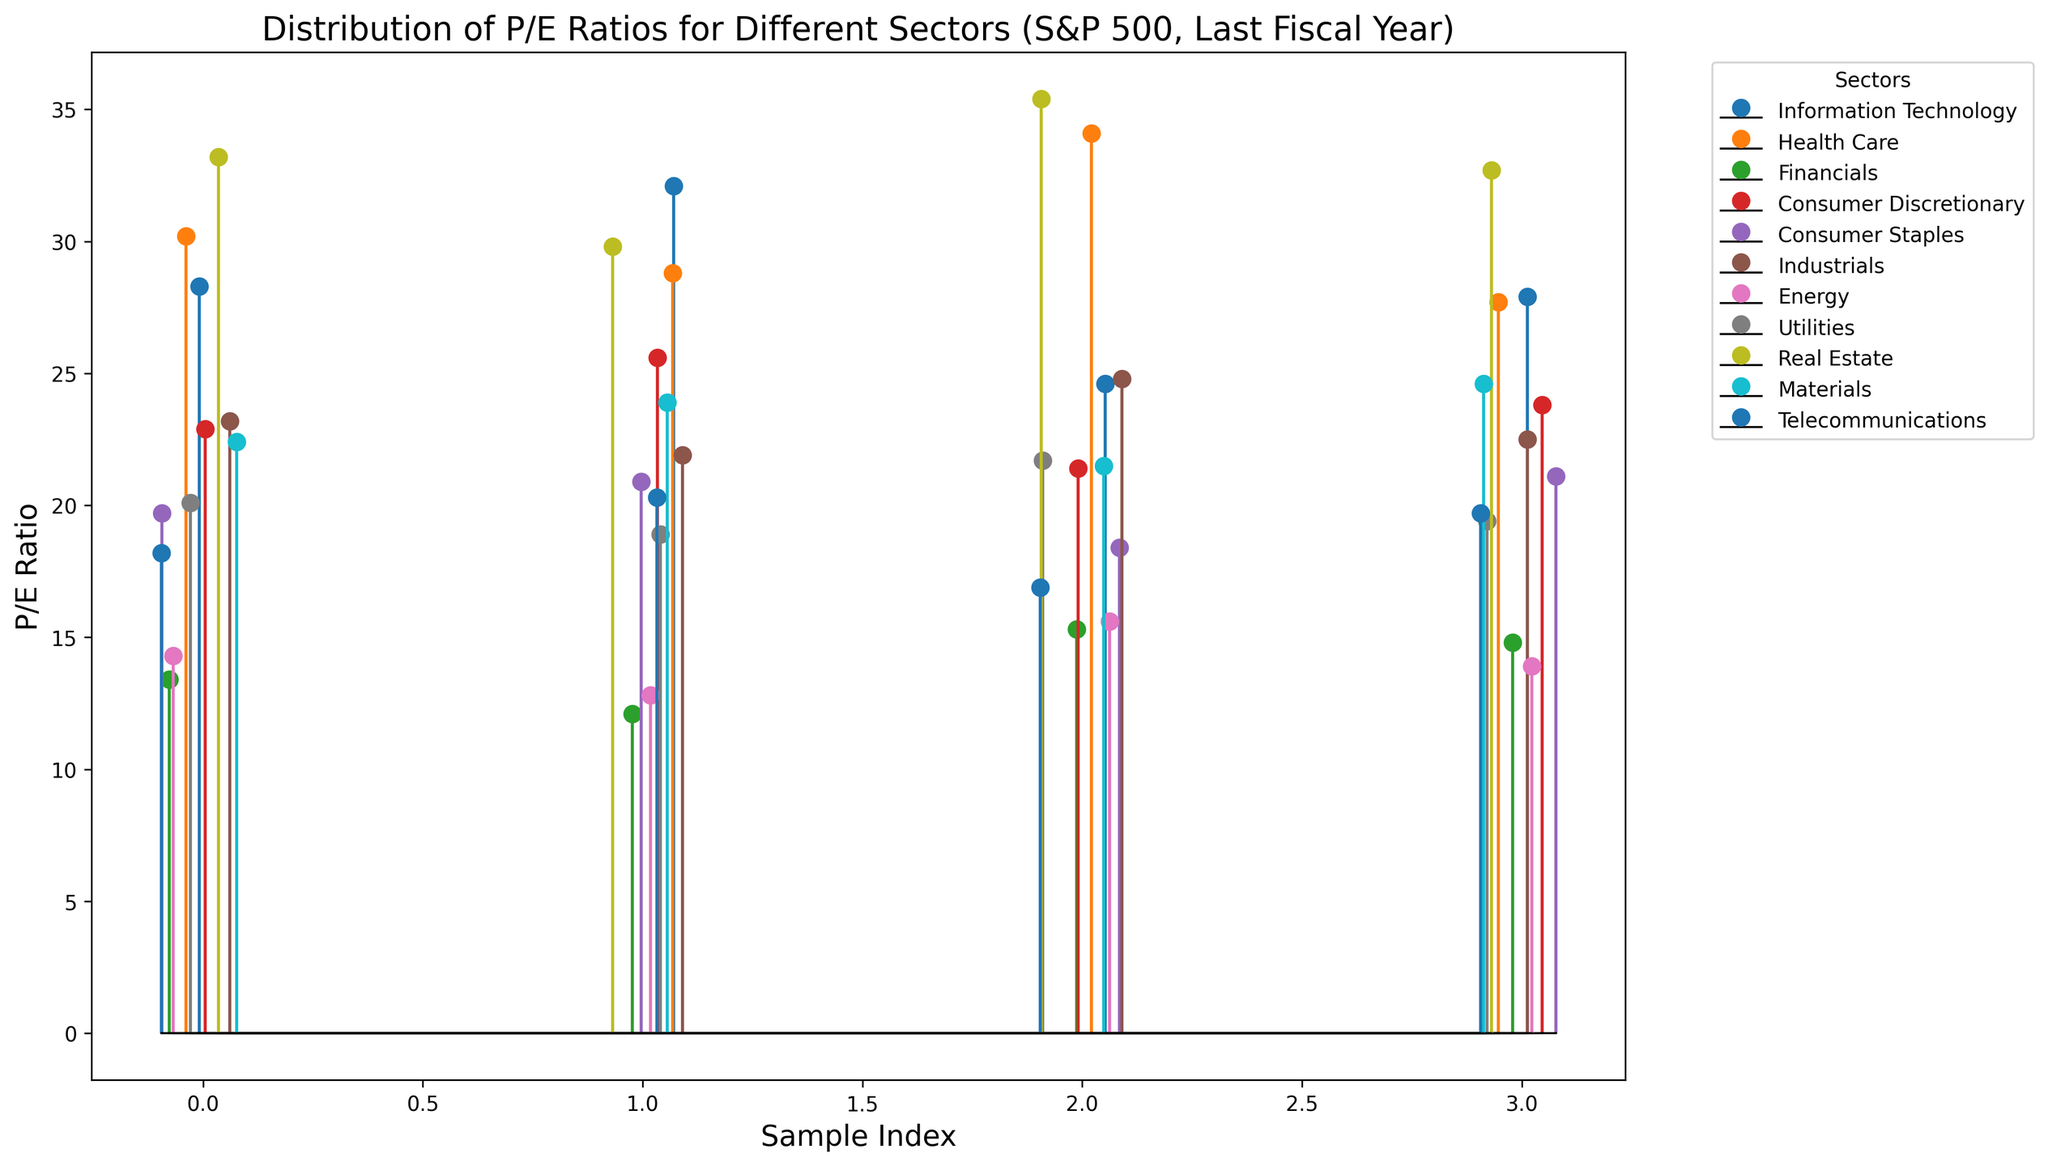What's the sector with the highest average P/E ratio? To find the sector with the highest average P/E ratio, first, calculate the average P/E for each sector by summing the P/E ratios of each sector and dividing by the number of data points. Information Technology (28.3+32.1+24.6+27.9)/4 = 28.225, Health Care (30.2+28.8+34.1+27.7)/4 = 30.2, Financials (13.4+12.1+15.3+14.8)/4 = 13.9, Consumer Discretionary (22.9+25.6+21.4+23.8)/4 = 23.425, Consumer Staples (19.7+20.9+18.4+21.1)/4 = 20.025, Industrials (23.2+21.9+24.8+22.5)/4 = 23.1, Energy (14.3+12.8+15.6+13.9)/4 = 14.15, Utilities (20.1+18.9+21.7+19.4)/4 = 20.025, Real Estate (33.2+29.8+35.4+32.7)/4 = 32.775, Materials (22.4+23.9+21.5+24.6)/4 = 23.1, Telecommunications (18.2+20.3+16.9+19.7)/4 = 18.775. Real Estate has the highest average P/E ratio at 32.775.
Answer: Real Estate What's the range of P/E ratios for the Financials sector? The range of the P/E ratios is the difference between the highest and lowest P/E ratios in the sector. For the Financials sector, the P/E ratios are 13.4, 12.1, 15.3, and 14.8. The highest is 15.3, and the lowest is 12.1, so the range is 15.3 - 12.1 = 3.2.
Answer: 3.2 Which sector appears to have the most consistent (least variable) P/E ratios? To determine which sector has the least variability, we compare the range (difference between the highest and lowest values) of P/E ratios for each sector. Calculating ranges: Information Technology (32.1-24.6=7.5), Health Care (34.1-27.7=6.4), Financials (15.3-12.1=3.2), Consumer Discretionary (25.6-21.4=4.2), Consumer Staples (21.1-18.4=2.7), Industrials (24.8-21.9=2.9), Energy (15.6-12.8=2.8), Utilities (21.7-18.9=2.8), Real Estate (35.4-29.8=5.6), Materials (24.6-21.5=3.1), Telecommunications (20.3-16.9=3.4). Consumer Staples and Utilities have the smallest range at 2.7 and 2.8 respectively, but Consumer Staples has the smallest range by a small margin. Therefore, Consumer Staples is the most consistent.
Answer: Consumer Staples What's the median P/E ratio for the Health Care sector? The median is the middle value of an ordered list. For the Health Care sector, the P/E ratios are 30.2, 28.8, 34.1, and 27.7. Ordered: 27.7, 28.8, 30.2, 34.1. The median is the average of the two middle numbers: (28.8 + 30.2)/2 = 29.5.
Answer: 29.5 Is the average P/E ratio of Information Technology higher than that of Consumer Discretionary? Calculate the averages: Information Technology (28.3+32.1+24.6+27.9)/4 = 28.225, Consumer Discretionary (22.9+25.6+21.4+23.8)/4 = 23.425. Compare the averages: 28.225 > 23.425, so yes, the average P/E ratio of Information Technology is higher than that of Consumer Discretionary.
Answer: Yes Are there any sectors with P/E ratios greater than 35? To determine this, scan through the P/E ratios provided. Real Estate has a P/E ratio of 35.4, which is greater than 35. None of the other sectors exceed 35.
Answer: Yes Which sector shows the largest disparity in P/E ratios (highest difference between maximum and minimum)? To determine the sector with the highest disparity, calculate the difference between the max and min P/E ratios for each sector. The disparities are: Information Technology (7.5), Health Care (6.4), Financials (3.2), Consumer Discretionary (4.2), Consumer Staples (2.7), Industrials (2.9), Energy (2.8), Utilities (2.8), Real Estate (5.6), Materials (3.1), Telecommunications (3.4). Therefore, Information Technology has the largest disparity at 7.5.
Answer: Information Technology 